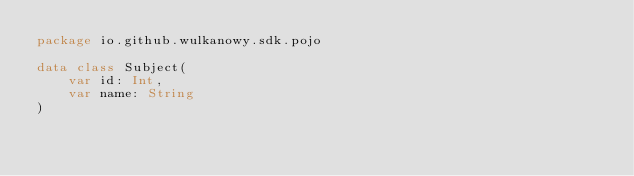<code> <loc_0><loc_0><loc_500><loc_500><_Kotlin_>package io.github.wulkanowy.sdk.pojo

data class Subject(
    var id: Int,
    var name: String
)
</code> 